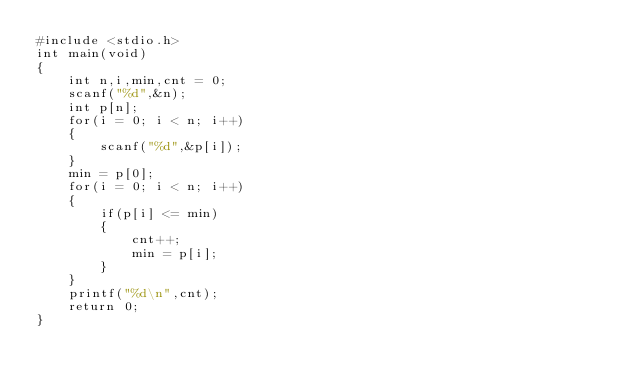<code> <loc_0><loc_0><loc_500><loc_500><_C_>#include <stdio.h>
int main(void)
{
    int n,i,min,cnt = 0;
    scanf("%d",&n);
    int p[n];
    for(i = 0; i < n; i++)
    {
        scanf("%d",&p[i]);
    }
    min = p[0];
    for(i = 0; i < n; i++)
    {
        if(p[i] <= min)
        {
            cnt++;
            min = p[i];
        }
    }
    printf("%d\n",cnt);
    return 0;
}
</code> 